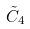<formula> <loc_0><loc_0><loc_500><loc_500>\tilde { C } _ { 4 }</formula> 